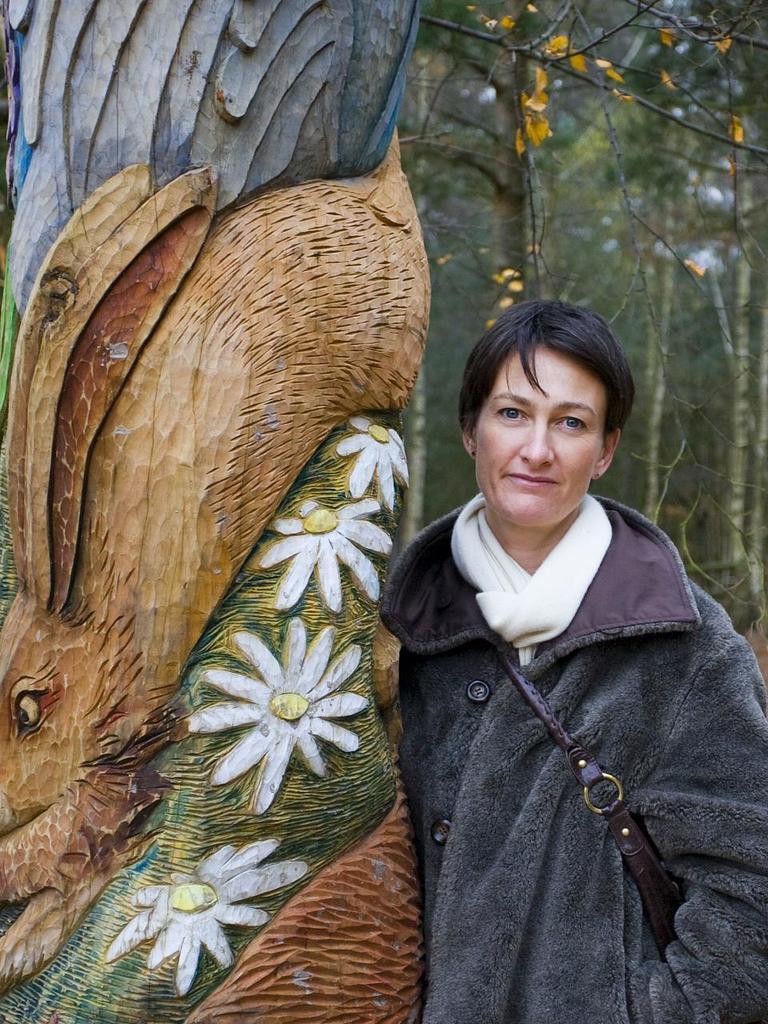Could you give a brief overview of what you see in this image? In this image a person wearing a jacket and scarf. He is standing beside a wooden trunk which is carved with the shape of flowers. Right side there are few trees. 